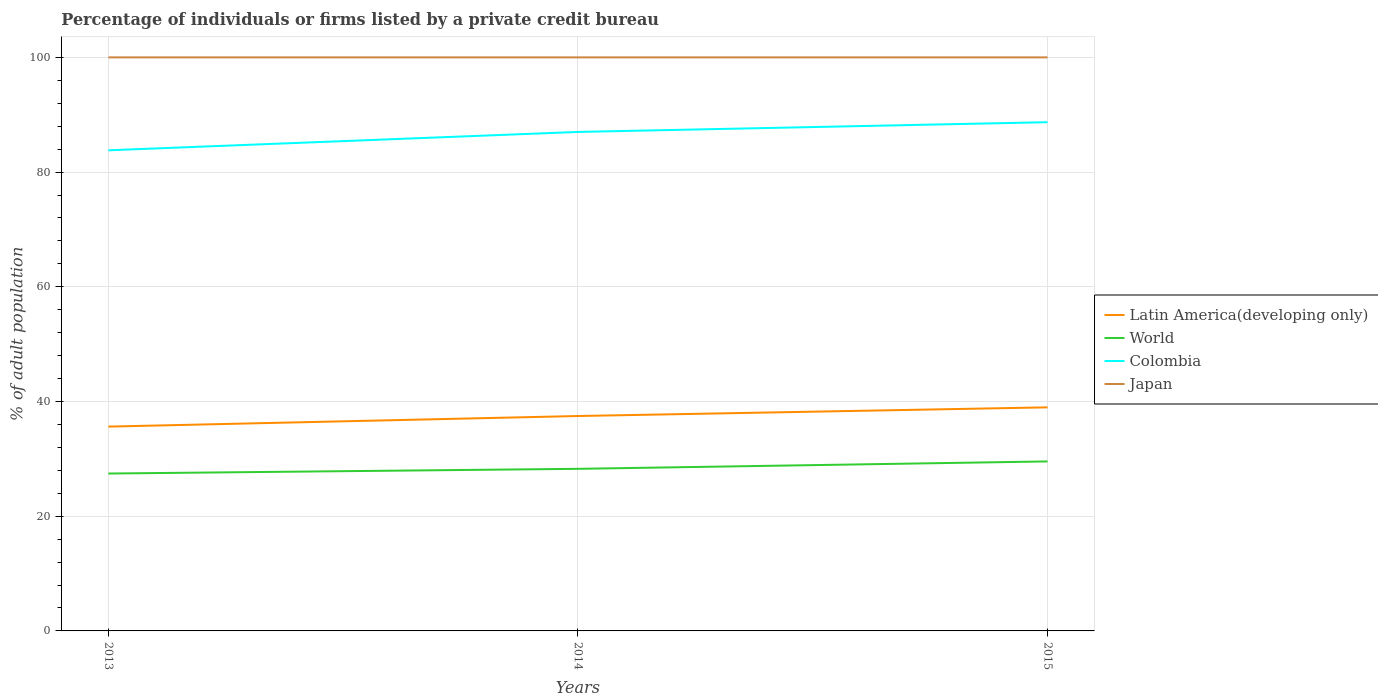How many different coloured lines are there?
Make the answer very short. 4. Does the line corresponding to Latin America(developing only) intersect with the line corresponding to Colombia?
Provide a succinct answer. No. Across all years, what is the maximum percentage of population listed by a private credit bureau in Latin America(developing only)?
Your answer should be very brief. 35.62. What is the total percentage of population listed by a private credit bureau in Latin America(developing only) in the graph?
Keep it short and to the point. -1.85. What is the difference between the highest and the lowest percentage of population listed by a private credit bureau in Japan?
Your answer should be very brief. 0. Is the percentage of population listed by a private credit bureau in Japan strictly greater than the percentage of population listed by a private credit bureau in Colombia over the years?
Provide a succinct answer. No. How many lines are there?
Provide a short and direct response. 4. How many years are there in the graph?
Keep it short and to the point. 3. What is the difference between two consecutive major ticks on the Y-axis?
Offer a terse response. 20. Are the values on the major ticks of Y-axis written in scientific E-notation?
Provide a succinct answer. No. Does the graph contain any zero values?
Provide a succinct answer. No. Where does the legend appear in the graph?
Provide a succinct answer. Center right. How are the legend labels stacked?
Offer a terse response. Vertical. What is the title of the graph?
Give a very brief answer. Percentage of individuals or firms listed by a private credit bureau. What is the label or title of the Y-axis?
Give a very brief answer. % of adult population. What is the % of adult population in Latin America(developing only) in 2013?
Your response must be concise. 35.62. What is the % of adult population in World in 2013?
Your answer should be very brief. 27.44. What is the % of adult population in Colombia in 2013?
Your answer should be compact. 83.8. What is the % of adult population of Japan in 2013?
Keep it short and to the point. 100. What is the % of adult population of Latin America(developing only) in 2014?
Ensure brevity in your answer.  37.47. What is the % of adult population in World in 2014?
Offer a very short reply. 28.26. What is the % of adult population in Japan in 2014?
Offer a terse response. 100. What is the % of adult population in Latin America(developing only) in 2015?
Make the answer very short. 38.98. What is the % of adult population in World in 2015?
Ensure brevity in your answer.  29.55. What is the % of adult population of Colombia in 2015?
Your answer should be compact. 88.7. What is the % of adult population in Japan in 2015?
Keep it short and to the point. 100. Across all years, what is the maximum % of adult population of Latin America(developing only)?
Keep it short and to the point. 38.98. Across all years, what is the maximum % of adult population in World?
Ensure brevity in your answer.  29.55. Across all years, what is the maximum % of adult population in Colombia?
Your answer should be very brief. 88.7. Across all years, what is the maximum % of adult population in Japan?
Provide a succinct answer. 100. Across all years, what is the minimum % of adult population of Latin America(developing only)?
Make the answer very short. 35.62. Across all years, what is the minimum % of adult population of World?
Make the answer very short. 27.44. Across all years, what is the minimum % of adult population in Colombia?
Offer a very short reply. 83.8. What is the total % of adult population of Latin America(developing only) in the graph?
Make the answer very short. 112.07. What is the total % of adult population of World in the graph?
Your response must be concise. 85.26. What is the total % of adult population in Colombia in the graph?
Ensure brevity in your answer.  259.5. What is the total % of adult population in Japan in the graph?
Give a very brief answer. 300. What is the difference between the % of adult population of Latin America(developing only) in 2013 and that in 2014?
Provide a succinct answer. -1.85. What is the difference between the % of adult population of World in 2013 and that in 2014?
Ensure brevity in your answer.  -0.82. What is the difference between the % of adult population of Colombia in 2013 and that in 2014?
Ensure brevity in your answer.  -3.2. What is the difference between the % of adult population in Latin America(developing only) in 2013 and that in 2015?
Your response must be concise. -3.36. What is the difference between the % of adult population in World in 2013 and that in 2015?
Provide a short and direct response. -2.11. What is the difference between the % of adult population of Japan in 2013 and that in 2015?
Offer a very short reply. 0. What is the difference between the % of adult population in Latin America(developing only) in 2014 and that in 2015?
Offer a very short reply. -1.51. What is the difference between the % of adult population of World in 2014 and that in 2015?
Make the answer very short. -1.29. What is the difference between the % of adult population in Colombia in 2014 and that in 2015?
Make the answer very short. -1.7. What is the difference between the % of adult population in Japan in 2014 and that in 2015?
Your answer should be compact. 0. What is the difference between the % of adult population of Latin America(developing only) in 2013 and the % of adult population of World in 2014?
Provide a succinct answer. 7.36. What is the difference between the % of adult population of Latin America(developing only) in 2013 and the % of adult population of Colombia in 2014?
Your answer should be very brief. -51.38. What is the difference between the % of adult population of Latin America(developing only) in 2013 and the % of adult population of Japan in 2014?
Keep it short and to the point. -64.38. What is the difference between the % of adult population in World in 2013 and the % of adult population in Colombia in 2014?
Provide a short and direct response. -59.56. What is the difference between the % of adult population in World in 2013 and the % of adult population in Japan in 2014?
Offer a terse response. -72.56. What is the difference between the % of adult population of Colombia in 2013 and the % of adult population of Japan in 2014?
Offer a terse response. -16.2. What is the difference between the % of adult population in Latin America(developing only) in 2013 and the % of adult population in World in 2015?
Offer a very short reply. 6.07. What is the difference between the % of adult population in Latin America(developing only) in 2013 and the % of adult population in Colombia in 2015?
Make the answer very short. -53.08. What is the difference between the % of adult population in Latin America(developing only) in 2013 and the % of adult population in Japan in 2015?
Offer a very short reply. -64.38. What is the difference between the % of adult population of World in 2013 and the % of adult population of Colombia in 2015?
Keep it short and to the point. -61.26. What is the difference between the % of adult population of World in 2013 and the % of adult population of Japan in 2015?
Ensure brevity in your answer.  -72.56. What is the difference between the % of adult population of Colombia in 2013 and the % of adult population of Japan in 2015?
Provide a succinct answer. -16.2. What is the difference between the % of adult population of Latin America(developing only) in 2014 and the % of adult population of World in 2015?
Offer a terse response. 7.92. What is the difference between the % of adult population of Latin America(developing only) in 2014 and the % of adult population of Colombia in 2015?
Provide a short and direct response. -51.23. What is the difference between the % of adult population of Latin America(developing only) in 2014 and the % of adult population of Japan in 2015?
Provide a succinct answer. -62.53. What is the difference between the % of adult population in World in 2014 and the % of adult population in Colombia in 2015?
Offer a terse response. -60.44. What is the difference between the % of adult population in World in 2014 and the % of adult population in Japan in 2015?
Your answer should be very brief. -71.74. What is the average % of adult population in Latin America(developing only) per year?
Offer a terse response. 37.36. What is the average % of adult population in World per year?
Offer a very short reply. 28.42. What is the average % of adult population in Colombia per year?
Offer a very short reply. 86.5. What is the average % of adult population in Japan per year?
Offer a terse response. 100. In the year 2013, what is the difference between the % of adult population in Latin America(developing only) and % of adult population in World?
Your response must be concise. 8.18. In the year 2013, what is the difference between the % of adult population in Latin America(developing only) and % of adult population in Colombia?
Make the answer very short. -48.18. In the year 2013, what is the difference between the % of adult population in Latin America(developing only) and % of adult population in Japan?
Keep it short and to the point. -64.38. In the year 2013, what is the difference between the % of adult population of World and % of adult population of Colombia?
Provide a succinct answer. -56.36. In the year 2013, what is the difference between the % of adult population of World and % of adult population of Japan?
Your response must be concise. -72.56. In the year 2013, what is the difference between the % of adult population in Colombia and % of adult population in Japan?
Your answer should be very brief. -16.2. In the year 2014, what is the difference between the % of adult population of Latin America(developing only) and % of adult population of World?
Make the answer very short. 9.21. In the year 2014, what is the difference between the % of adult population in Latin America(developing only) and % of adult population in Colombia?
Your answer should be compact. -49.53. In the year 2014, what is the difference between the % of adult population of Latin America(developing only) and % of adult population of Japan?
Your answer should be very brief. -62.53. In the year 2014, what is the difference between the % of adult population in World and % of adult population in Colombia?
Provide a succinct answer. -58.74. In the year 2014, what is the difference between the % of adult population in World and % of adult population in Japan?
Keep it short and to the point. -71.74. In the year 2015, what is the difference between the % of adult population of Latin America(developing only) and % of adult population of World?
Your response must be concise. 9.43. In the year 2015, what is the difference between the % of adult population in Latin America(developing only) and % of adult population in Colombia?
Make the answer very short. -49.72. In the year 2015, what is the difference between the % of adult population of Latin America(developing only) and % of adult population of Japan?
Provide a short and direct response. -61.02. In the year 2015, what is the difference between the % of adult population in World and % of adult population in Colombia?
Offer a terse response. -59.15. In the year 2015, what is the difference between the % of adult population of World and % of adult population of Japan?
Offer a terse response. -70.45. What is the ratio of the % of adult population in Latin America(developing only) in 2013 to that in 2014?
Offer a terse response. 0.95. What is the ratio of the % of adult population of Colombia in 2013 to that in 2014?
Your answer should be compact. 0.96. What is the ratio of the % of adult population of Latin America(developing only) in 2013 to that in 2015?
Your response must be concise. 0.91. What is the ratio of the % of adult population in World in 2013 to that in 2015?
Your answer should be very brief. 0.93. What is the ratio of the % of adult population of Colombia in 2013 to that in 2015?
Keep it short and to the point. 0.94. What is the ratio of the % of adult population in Japan in 2013 to that in 2015?
Provide a succinct answer. 1. What is the ratio of the % of adult population of Latin America(developing only) in 2014 to that in 2015?
Your response must be concise. 0.96. What is the ratio of the % of adult population in World in 2014 to that in 2015?
Ensure brevity in your answer.  0.96. What is the ratio of the % of adult population of Colombia in 2014 to that in 2015?
Your answer should be very brief. 0.98. What is the difference between the highest and the second highest % of adult population of Latin America(developing only)?
Your response must be concise. 1.51. What is the difference between the highest and the second highest % of adult population in World?
Your response must be concise. 1.29. What is the difference between the highest and the second highest % of adult population of Colombia?
Ensure brevity in your answer.  1.7. What is the difference between the highest and the second highest % of adult population of Japan?
Provide a short and direct response. 0. What is the difference between the highest and the lowest % of adult population in Latin America(developing only)?
Offer a very short reply. 3.36. What is the difference between the highest and the lowest % of adult population in World?
Ensure brevity in your answer.  2.11. What is the difference between the highest and the lowest % of adult population in Colombia?
Offer a very short reply. 4.9. What is the difference between the highest and the lowest % of adult population of Japan?
Provide a short and direct response. 0. 